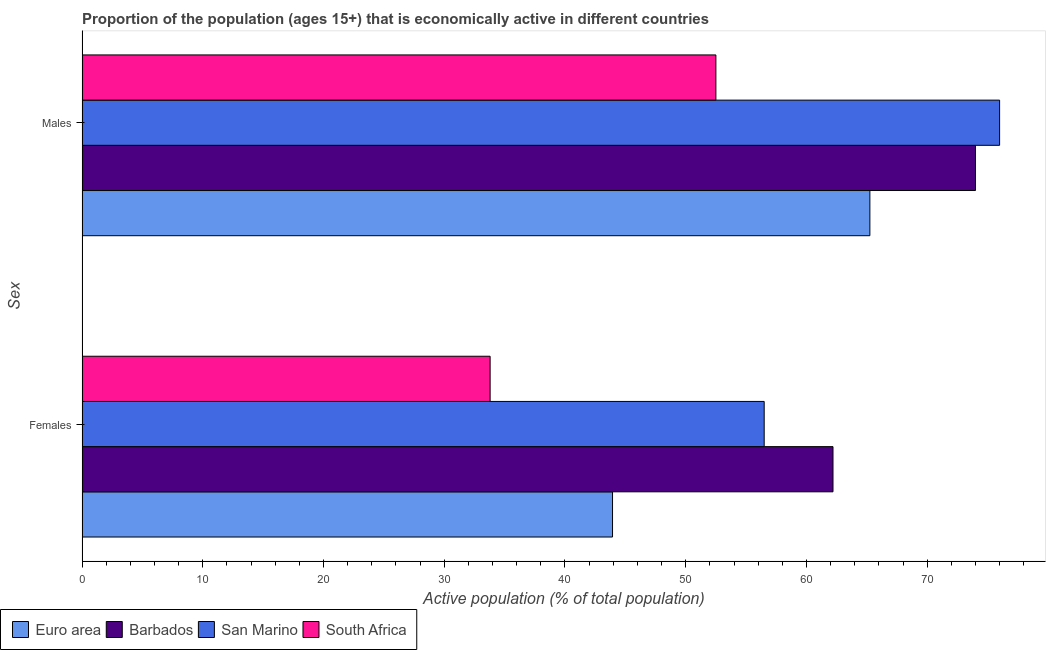How many groups of bars are there?
Provide a succinct answer. 2. How many bars are there on the 1st tick from the top?
Ensure brevity in your answer.  4. How many bars are there on the 1st tick from the bottom?
Your response must be concise. 4. What is the label of the 1st group of bars from the top?
Your response must be concise. Males. Across all countries, what is the maximum percentage of economically active female population?
Provide a short and direct response. 62.2. Across all countries, what is the minimum percentage of economically active male population?
Offer a very short reply. 52.5. In which country was the percentage of economically active male population maximum?
Keep it short and to the point. San Marino. In which country was the percentage of economically active male population minimum?
Your answer should be compact. South Africa. What is the total percentage of economically active male population in the graph?
Provide a succinct answer. 267.75. What is the difference between the percentage of economically active male population in Euro area and that in South Africa?
Provide a succinct answer. 12.75. What is the difference between the percentage of economically active female population in South Africa and the percentage of economically active male population in Euro area?
Your response must be concise. -31.45. What is the average percentage of economically active male population per country?
Make the answer very short. 66.94. What is the difference between the percentage of economically active male population and percentage of economically active female population in South Africa?
Your answer should be very brief. 18.7. In how many countries, is the percentage of economically active male population greater than 54 %?
Offer a terse response. 3. What is the ratio of the percentage of economically active male population in Barbados to that in Euro area?
Keep it short and to the point. 1.13. In how many countries, is the percentage of economically active female population greater than the average percentage of economically active female population taken over all countries?
Keep it short and to the point. 2. What does the 2nd bar from the top in Females represents?
Ensure brevity in your answer.  San Marino. What does the 1st bar from the bottom in Females represents?
Make the answer very short. Euro area. Are all the bars in the graph horizontal?
Offer a very short reply. Yes. Where does the legend appear in the graph?
Provide a succinct answer. Bottom left. How many legend labels are there?
Give a very brief answer. 4. How are the legend labels stacked?
Ensure brevity in your answer.  Horizontal. What is the title of the graph?
Give a very brief answer. Proportion of the population (ages 15+) that is economically active in different countries. What is the label or title of the X-axis?
Keep it short and to the point. Active population (% of total population). What is the label or title of the Y-axis?
Your answer should be very brief. Sex. What is the Active population (% of total population) of Euro area in Females?
Provide a short and direct response. 43.94. What is the Active population (% of total population) in Barbados in Females?
Make the answer very short. 62.2. What is the Active population (% of total population) of San Marino in Females?
Provide a short and direct response. 56.5. What is the Active population (% of total population) in South Africa in Females?
Keep it short and to the point. 33.8. What is the Active population (% of total population) in Euro area in Males?
Provide a succinct answer. 65.25. What is the Active population (% of total population) in South Africa in Males?
Provide a succinct answer. 52.5. Across all Sex, what is the maximum Active population (% of total population) in Euro area?
Give a very brief answer. 65.25. Across all Sex, what is the maximum Active population (% of total population) of Barbados?
Provide a succinct answer. 74. Across all Sex, what is the maximum Active population (% of total population) of San Marino?
Your answer should be compact. 76. Across all Sex, what is the maximum Active population (% of total population) in South Africa?
Keep it short and to the point. 52.5. Across all Sex, what is the minimum Active population (% of total population) in Euro area?
Your answer should be compact. 43.94. Across all Sex, what is the minimum Active population (% of total population) in Barbados?
Your response must be concise. 62.2. Across all Sex, what is the minimum Active population (% of total population) of San Marino?
Your answer should be very brief. 56.5. Across all Sex, what is the minimum Active population (% of total population) of South Africa?
Keep it short and to the point. 33.8. What is the total Active population (% of total population) of Euro area in the graph?
Offer a terse response. 109.19. What is the total Active population (% of total population) of Barbados in the graph?
Give a very brief answer. 136.2. What is the total Active population (% of total population) of San Marino in the graph?
Your answer should be very brief. 132.5. What is the total Active population (% of total population) in South Africa in the graph?
Give a very brief answer. 86.3. What is the difference between the Active population (% of total population) in Euro area in Females and that in Males?
Your answer should be very brief. -21.31. What is the difference between the Active population (% of total population) of San Marino in Females and that in Males?
Give a very brief answer. -19.5. What is the difference between the Active population (% of total population) in South Africa in Females and that in Males?
Offer a terse response. -18.7. What is the difference between the Active population (% of total population) of Euro area in Females and the Active population (% of total population) of Barbados in Males?
Provide a succinct answer. -30.06. What is the difference between the Active population (% of total population) in Euro area in Females and the Active population (% of total population) in San Marino in Males?
Ensure brevity in your answer.  -32.06. What is the difference between the Active population (% of total population) of Euro area in Females and the Active population (% of total population) of South Africa in Males?
Your answer should be compact. -8.56. What is the difference between the Active population (% of total population) in San Marino in Females and the Active population (% of total population) in South Africa in Males?
Offer a terse response. 4. What is the average Active population (% of total population) of Euro area per Sex?
Offer a very short reply. 54.6. What is the average Active population (% of total population) in Barbados per Sex?
Offer a terse response. 68.1. What is the average Active population (% of total population) of San Marino per Sex?
Give a very brief answer. 66.25. What is the average Active population (% of total population) in South Africa per Sex?
Ensure brevity in your answer.  43.15. What is the difference between the Active population (% of total population) in Euro area and Active population (% of total population) in Barbados in Females?
Your answer should be very brief. -18.26. What is the difference between the Active population (% of total population) in Euro area and Active population (% of total population) in San Marino in Females?
Give a very brief answer. -12.56. What is the difference between the Active population (% of total population) of Euro area and Active population (% of total population) of South Africa in Females?
Make the answer very short. 10.14. What is the difference between the Active population (% of total population) in Barbados and Active population (% of total population) in South Africa in Females?
Keep it short and to the point. 28.4. What is the difference between the Active population (% of total population) in San Marino and Active population (% of total population) in South Africa in Females?
Your answer should be compact. 22.7. What is the difference between the Active population (% of total population) of Euro area and Active population (% of total population) of Barbados in Males?
Offer a terse response. -8.75. What is the difference between the Active population (% of total population) in Euro area and Active population (% of total population) in San Marino in Males?
Provide a succinct answer. -10.75. What is the difference between the Active population (% of total population) in Euro area and Active population (% of total population) in South Africa in Males?
Your answer should be compact. 12.75. What is the difference between the Active population (% of total population) in Barbados and Active population (% of total population) in San Marino in Males?
Give a very brief answer. -2. What is the difference between the Active population (% of total population) in San Marino and Active population (% of total population) in South Africa in Males?
Provide a succinct answer. 23.5. What is the ratio of the Active population (% of total population) of Euro area in Females to that in Males?
Offer a very short reply. 0.67. What is the ratio of the Active population (% of total population) of Barbados in Females to that in Males?
Your answer should be compact. 0.84. What is the ratio of the Active population (% of total population) of San Marino in Females to that in Males?
Keep it short and to the point. 0.74. What is the ratio of the Active population (% of total population) in South Africa in Females to that in Males?
Ensure brevity in your answer.  0.64. What is the difference between the highest and the second highest Active population (% of total population) of Euro area?
Provide a succinct answer. 21.31. What is the difference between the highest and the second highest Active population (% of total population) of San Marino?
Make the answer very short. 19.5. What is the difference between the highest and the second highest Active population (% of total population) in South Africa?
Keep it short and to the point. 18.7. What is the difference between the highest and the lowest Active population (% of total population) in Euro area?
Your response must be concise. 21.31. What is the difference between the highest and the lowest Active population (% of total population) of San Marino?
Offer a terse response. 19.5. 